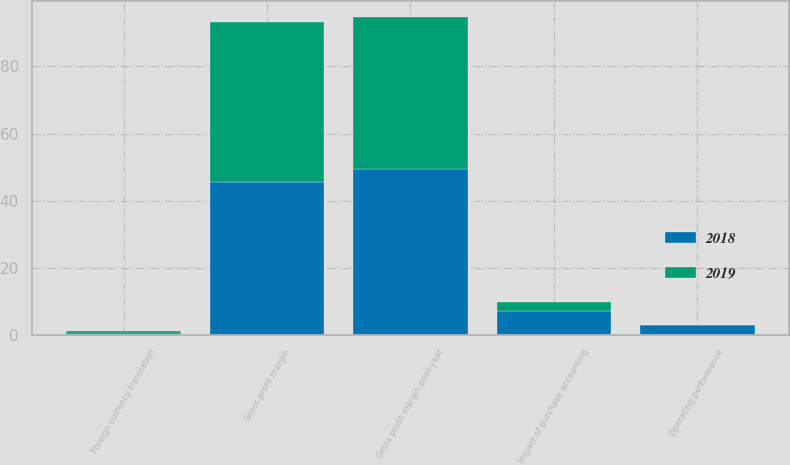Convert chart. <chart><loc_0><loc_0><loc_500><loc_500><stacked_bar_chart><ecel><fcel>Gross profit margin prior-year<fcel>Impact of purchase accounting<fcel>Operating performance<fcel>Foreign currency translation<fcel>Gross profit margin<nl><fcel>2019<fcel>45.5<fcel>2.9<fcel>0.1<fcel>0.6<fcel>47.9<nl><fcel>2018<fcel>49.3<fcel>6.9<fcel>2.7<fcel>0.4<fcel>45.5<nl></chart> 